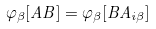Convert formula to latex. <formula><loc_0><loc_0><loc_500><loc_500>\varphi _ { \beta } [ A B ] = \varphi _ { \beta } [ B A _ { i \beta } ]</formula> 